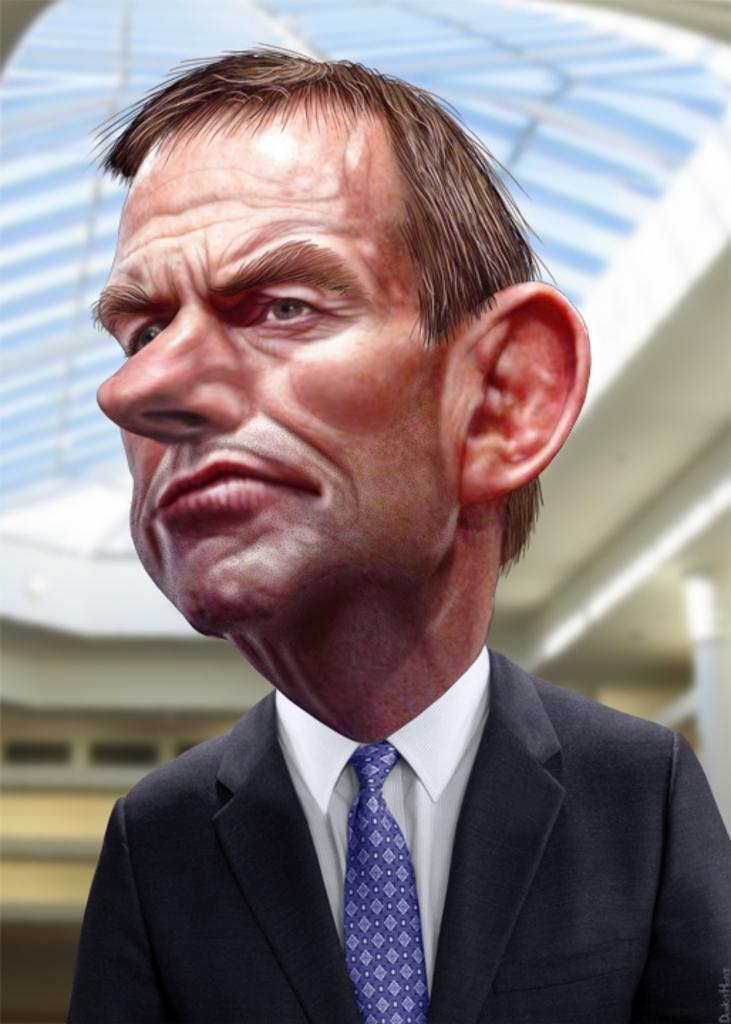Describe this image in one or two sentences. In front of the image there is a depiction of a person. Behind him there is a building. There is some text at the bottom of the image. 